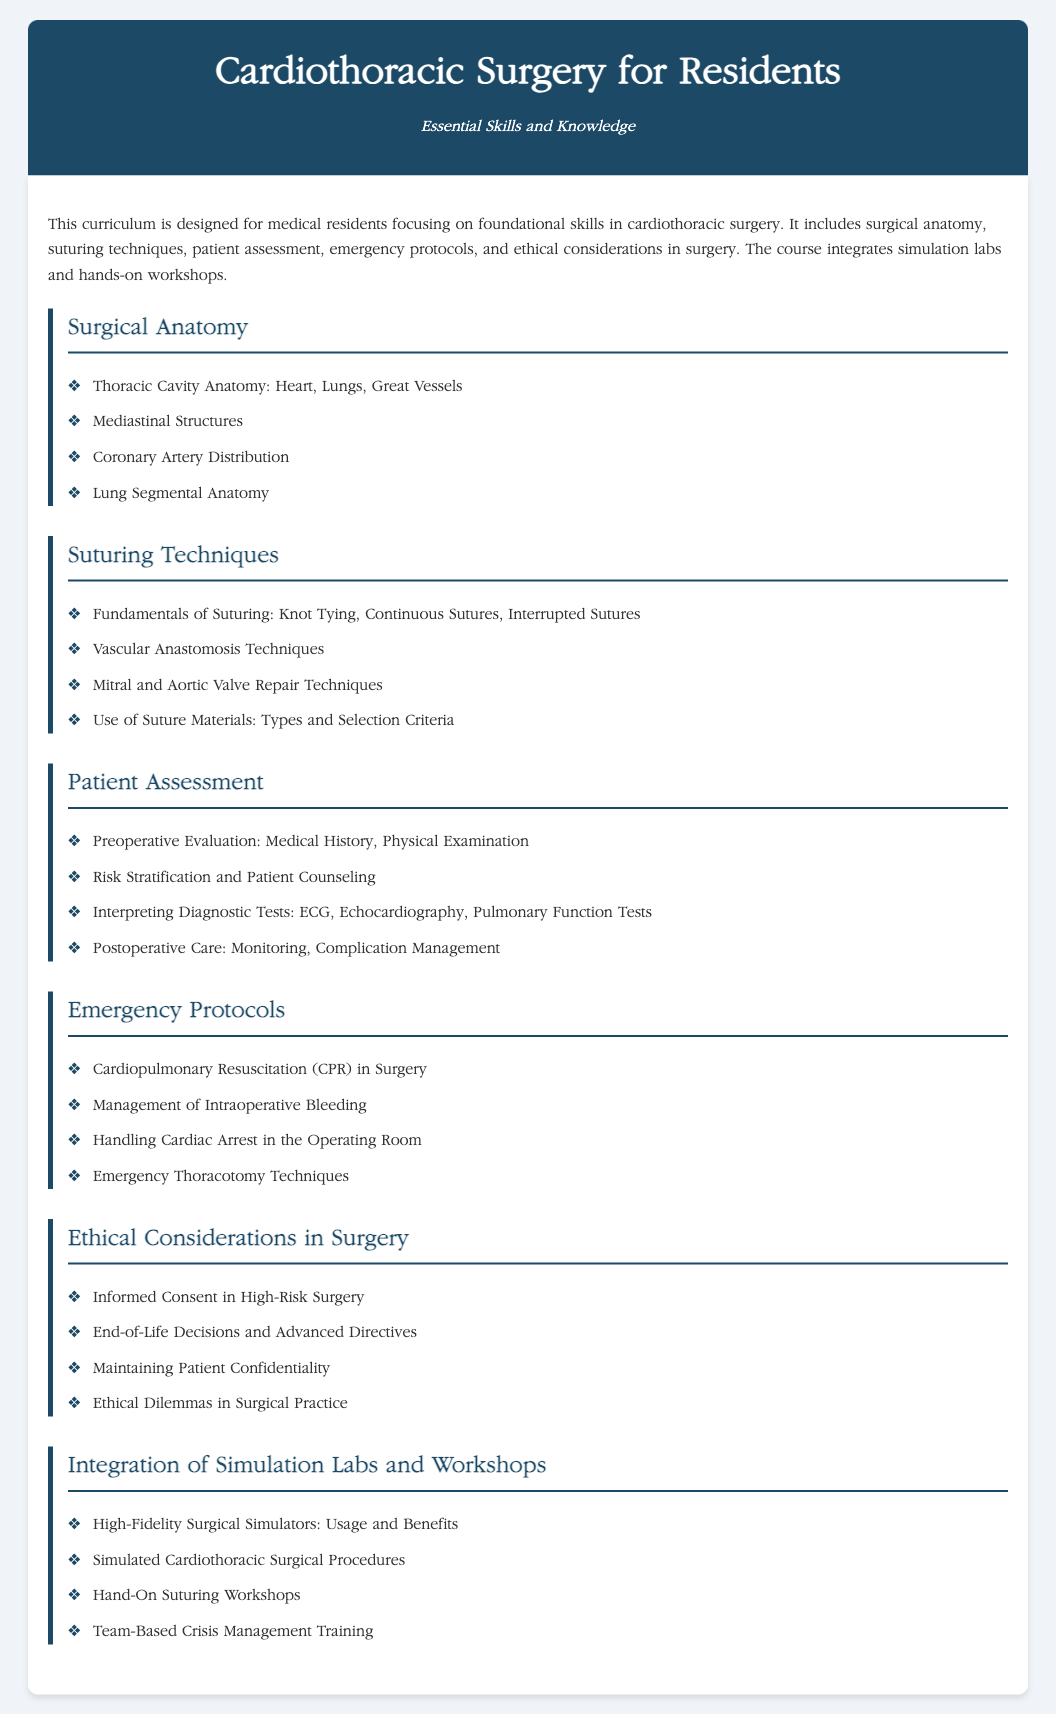What is the title of the curriculum? The title of the curriculum is mentioned in the header of the document.
Answer: Cardiothoracic Surgery for Residents What is emphasized in the course description? The course description highlights its focus on foundational skills in cardiothoracic surgery.
Answer: Foundational skills in cardiothoracic surgery Name one aspect covered in the "Surgical Anatomy" section. The document lists several anatomical structures included in the section on surgical anatomy.
Answer: Thoracic Cavity Anatomy What technique is introduced in the "Suturing Techniques" section? The document specifically highlights various suturing methods within this section.
Answer: Knot Tying Which patient evaluation method is mentioned in the "Patient Assessment" section? The document specifies what evaluations are included under patient assessment.
Answer: Medical History What is one emergency protocol covered in the corresponding section? The document lists several protocols, indicating the emergency situations addressed.
Answer: Management of Intraoperative Bleeding What type of training is integrated within the curriculum? The document describes a specific form of training included in the course structure.
Answer: Team-Based Crisis Management Training What ethical issue is addressed in the "Ethical Considerations in Surgery" section? The document mentions certain ethical dilemmas that are critical to surgical practices.
Answer: Ethical Dilemmas in Surgical Practice What is the benefit highlighted for high-fidelity surgical simulators? The document states a benefit of using high-fidelity surgical simulators in training.
Answer: Usage and Benefits 